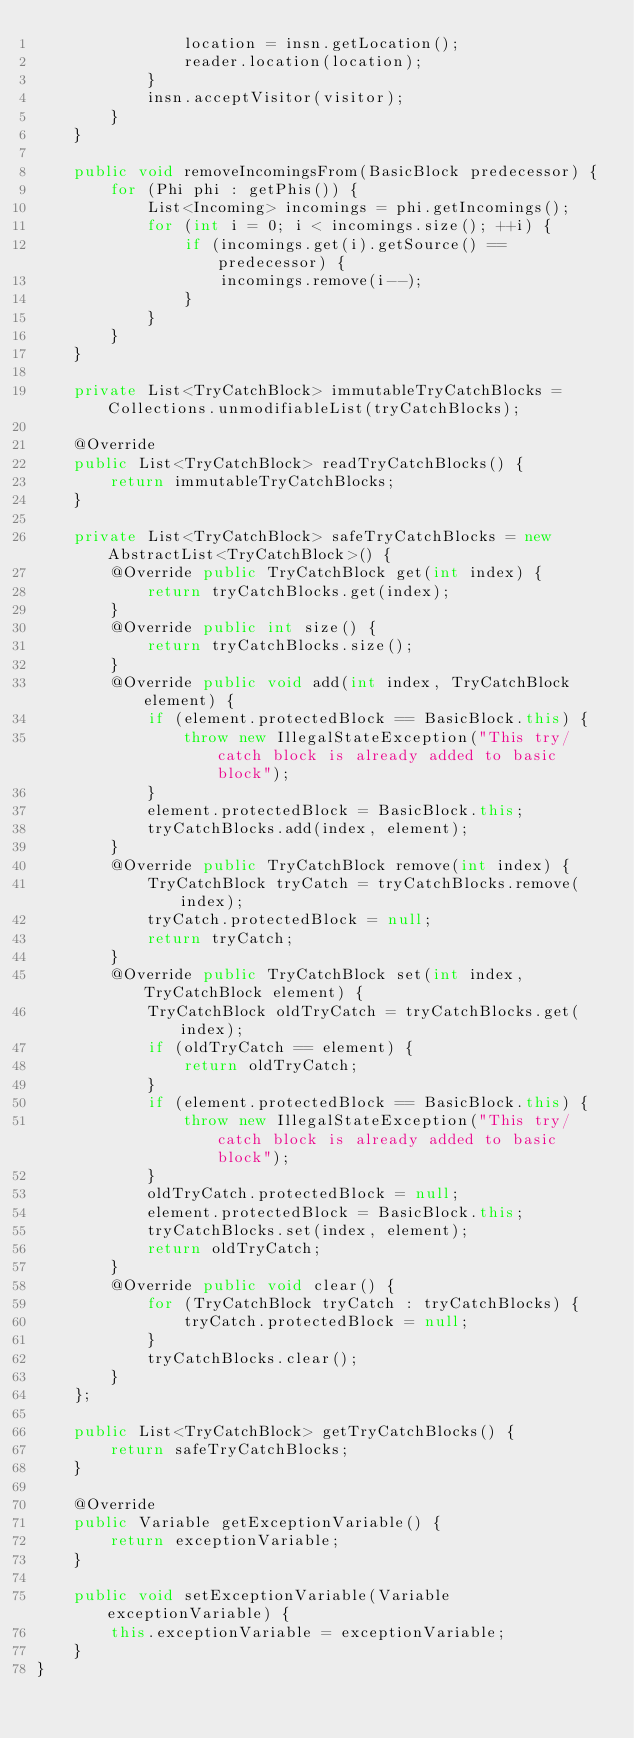Convert code to text. <code><loc_0><loc_0><loc_500><loc_500><_Java_>                location = insn.getLocation();
                reader.location(location);
            }
            insn.acceptVisitor(visitor);
        }
    }

    public void removeIncomingsFrom(BasicBlock predecessor) {
        for (Phi phi : getPhis()) {
            List<Incoming> incomings = phi.getIncomings();
            for (int i = 0; i < incomings.size(); ++i) {
                if (incomings.get(i).getSource() == predecessor) {
                    incomings.remove(i--);
                }
            }
        }
    }

    private List<TryCatchBlock> immutableTryCatchBlocks = Collections.unmodifiableList(tryCatchBlocks);

    @Override
    public List<TryCatchBlock> readTryCatchBlocks() {
        return immutableTryCatchBlocks;
    }

    private List<TryCatchBlock> safeTryCatchBlocks = new AbstractList<TryCatchBlock>() {
        @Override public TryCatchBlock get(int index) {
            return tryCatchBlocks.get(index);
        }
        @Override public int size() {
            return tryCatchBlocks.size();
        }
        @Override public void add(int index, TryCatchBlock element) {
            if (element.protectedBlock == BasicBlock.this) {
                throw new IllegalStateException("This try/catch block is already added to basic block");
            }
            element.protectedBlock = BasicBlock.this;
            tryCatchBlocks.add(index, element);
        }
        @Override public TryCatchBlock remove(int index) {
            TryCatchBlock tryCatch = tryCatchBlocks.remove(index);
            tryCatch.protectedBlock = null;
            return tryCatch;
        }
        @Override public TryCatchBlock set(int index, TryCatchBlock element) {
            TryCatchBlock oldTryCatch = tryCatchBlocks.get(index);
            if (oldTryCatch == element) {
                return oldTryCatch;
            }
            if (element.protectedBlock == BasicBlock.this) {
                throw new IllegalStateException("This try/catch block is already added to basic block");
            }
            oldTryCatch.protectedBlock = null;
            element.protectedBlock = BasicBlock.this;
            tryCatchBlocks.set(index, element);
            return oldTryCatch;
        }
        @Override public void clear() {
            for (TryCatchBlock tryCatch : tryCatchBlocks) {
                tryCatch.protectedBlock = null;
            }
            tryCatchBlocks.clear();
        }
    };

    public List<TryCatchBlock> getTryCatchBlocks() {
        return safeTryCatchBlocks;
    }

    @Override
    public Variable getExceptionVariable() {
        return exceptionVariable;
    }

    public void setExceptionVariable(Variable exceptionVariable) {
        this.exceptionVariable = exceptionVariable;
    }
}
</code> 